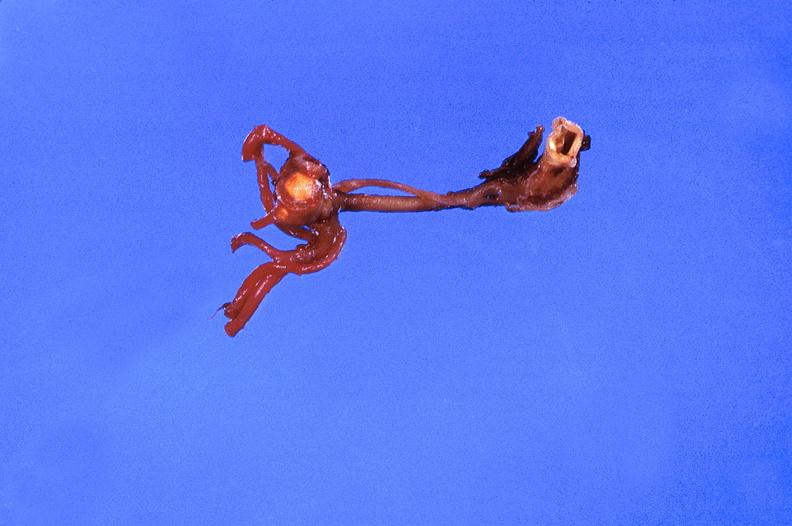does this image show ruptured saccular aneurysm right middle cerebral artery?
Answer the question using a single word or phrase. Yes 